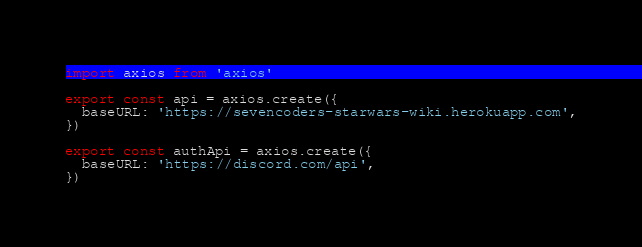Convert code to text. <code><loc_0><loc_0><loc_500><loc_500><_TypeScript_>import axios from 'axios'

export const api = axios.create({
  baseURL: 'https://sevencoders-starwars-wiki.herokuapp.com',
})

export const authApi = axios.create({
  baseURL: 'https://discord.com/api',
})
</code> 